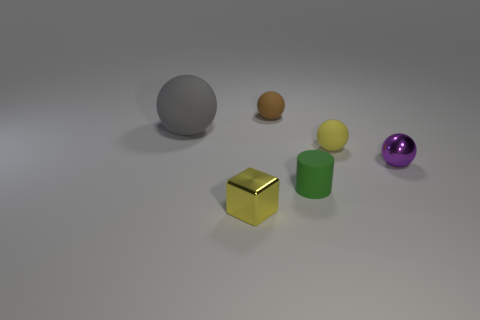What number of things are on the left side of the tiny green cylinder and to the right of the small yellow shiny object?
Provide a short and direct response. 1. Is the number of small purple balls that are on the left side of the small purple object the same as the number of yellow metal blocks that are in front of the metallic cube?
Give a very brief answer. Yes. Does the shiny object that is on the right side of the yellow shiny object have the same size as the rubber sphere in front of the gray matte object?
Provide a succinct answer. Yes. There is a small ball that is to the left of the purple metallic sphere and right of the brown rubber sphere; what material is it made of?
Provide a short and direct response. Rubber. Is the number of green cylinders less than the number of large red metal objects?
Provide a succinct answer. No. What is the size of the metallic thing that is on the right side of the yellow thing on the right side of the tiny green thing?
Offer a very short reply. Small. The tiny shiny object in front of the thing to the right of the yellow object that is behind the purple metal thing is what shape?
Provide a short and direct response. Cube. There is a cylinder that is made of the same material as the large sphere; what color is it?
Offer a very short reply. Green. What is the color of the small matte sphere on the left side of the small rubber ball that is in front of the tiny matte ball behind the large gray object?
Your response must be concise. Brown. What number of spheres are big objects or small green objects?
Provide a short and direct response. 1. 